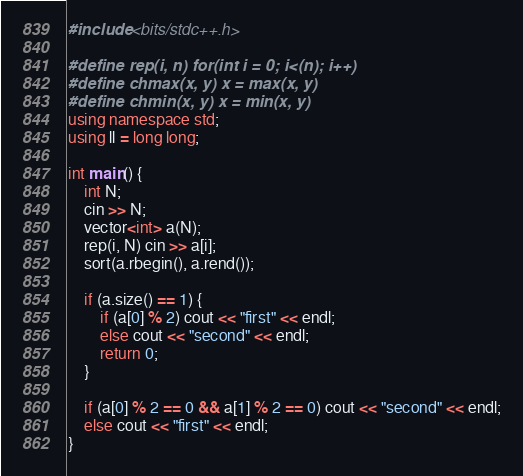Convert code to text. <code><loc_0><loc_0><loc_500><loc_500><_C++_>#include <bits/stdc++.h>

#define rep(i, n) for(int i = 0; i<(n); i++)
#define chmax(x, y) x = max(x, y)
#define chmin(x, y) x = min(x, y)
using namespace std;
using ll = long long;

int main() {
    int N;
    cin >> N;
    vector<int> a(N);
    rep(i, N) cin >> a[i];
    sort(a.rbegin(), a.rend());

    if (a.size() == 1) {
        if (a[0] % 2) cout << "first" << endl;
        else cout << "second" << endl;
        return 0;
    }

    if (a[0] % 2 == 0 && a[1] % 2 == 0) cout << "second" << endl;
    else cout << "first" << endl;
}
</code> 